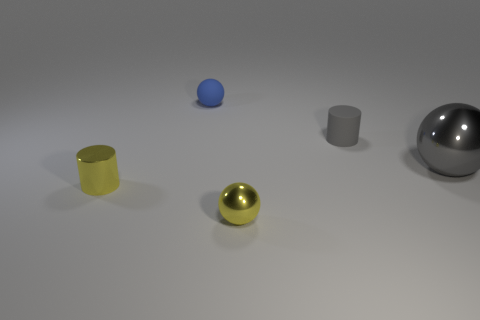Is there any other thing that is the same size as the gray metallic object?
Your answer should be very brief. No. What size is the gray sphere that is the same material as the tiny yellow ball?
Make the answer very short. Large. How many shiny objects are tiny yellow balls or cylinders?
Provide a short and direct response. 2. The gray ball has what size?
Give a very brief answer. Large. Do the blue ball and the gray ball have the same size?
Ensure brevity in your answer.  No. There is a gray ball that is to the right of the small gray matte thing; what material is it?
Give a very brief answer. Metal. What is the material of the blue object that is the same shape as the large gray metal thing?
Provide a short and direct response. Rubber. There is a cylinder behind the large metal sphere; is there a small blue rubber thing that is in front of it?
Give a very brief answer. No. Is the big metallic thing the same shape as the blue object?
Provide a short and direct response. Yes. There is a small thing that is made of the same material as the tiny gray cylinder; what shape is it?
Offer a terse response. Sphere. 